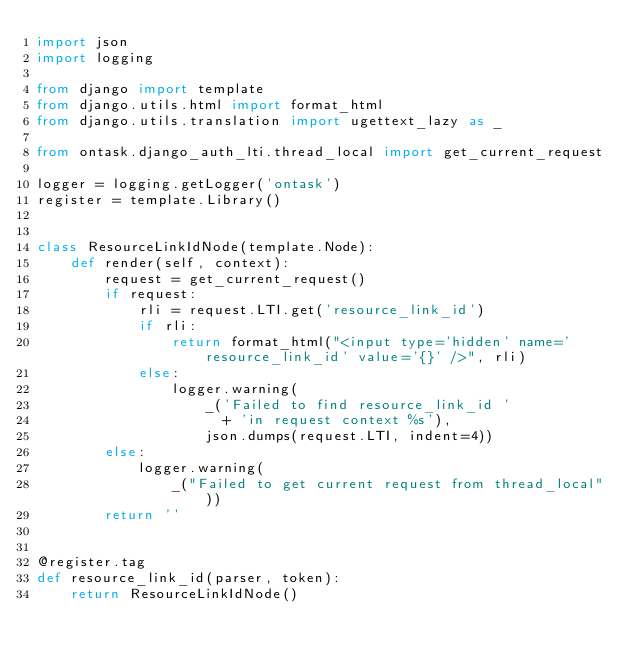<code> <loc_0><loc_0><loc_500><loc_500><_Python_>import json
import logging

from django import template
from django.utils.html import format_html
from django.utils.translation import ugettext_lazy as _

from ontask.django_auth_lti.thread_local import get_current_request

logger = logging.getLogger('ontask')
register = template.Library()


class ResourceLinkIdNode(template.Node):
    def render(self, context):
        request = get_current_request()
        if request:
            rli = request.LTI.get('resource_link_id')
            if rli:
                return format_html("<input type='hidden' name='resource_link_id' value='{}' />", rli)
            else:
                logger.warning(
                    _('Failed to find resource_link_id '
                      + 'in request context %s'),
                    json.dumps(request.LTI, indent=4))
        else:
            logger.warning(
                _("Failed to get current request from thread_local"))
        return ''


@register.tag
def resource_link_id(parser, token):
    return ResourceLinkIdNode()
</code> 